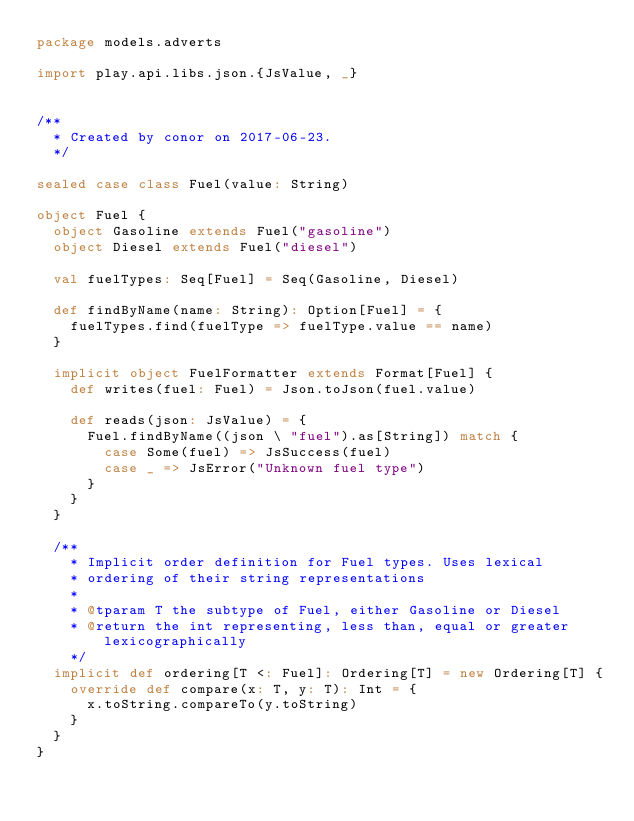Convert code to text. <code><loc_0><loc_0><loc_500><loc_500><_Scala_>package models.adverts

import play.api.libs.json.{JsValue, _}


/**
  * Created by conor on 2017-06-23.
  */

sealed case class Fuel(value: String)

object Fuel {
  object Gasoline extends Fuel("gasoline")
  object Diesel extends Fuel("diesel")

  val fuelTypes: Seq[Fuel] = Seq(Gasoline, Diesel)

  def findByName(name: String): Option[Fuel] = {
    fuelTypes.find(fuelType => fuelType.value == name)
  }

  implicit object FuelFormatter extends Format[Fuel] {
    def writes(fuel: Fuel) = Json.toJson(fuel.value)

    def reads(json: JsValue) = {
      Fuel.findByName((json \ "fuel").as[String]) match {
        case Some(fuel) => JsSuccess(fuel)
        case _ => JsError("Unknown fuel type")
      }
    }
  }

  /**
    * Implicit order definition for Fuel types. Uses lexical
    * ordering of their string representations
    *
    * @tparam T the subtype of Fuel, either Gasoline or Diesel
    * @return the int representing, less than, equal or greater lexicographically
    */
  implicit def ordering[T <: Fuel]: Ordering[T] = new Ordering[T] {
    override def compare(x: T, y: T): Int = {
      x.toString.compareTo(y.toString)
    }
  }
}
</code> 